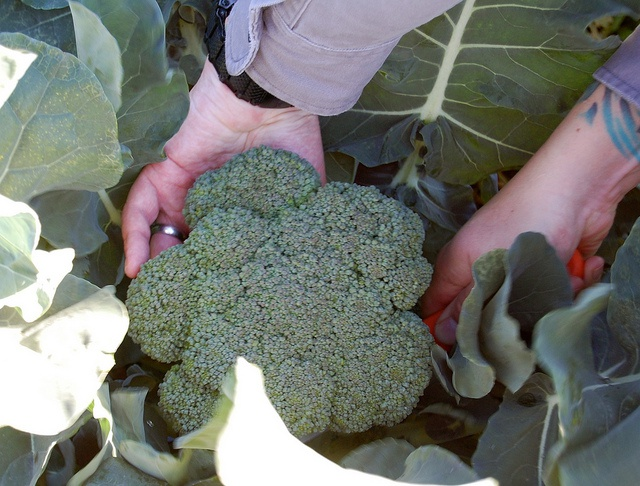Describe the objects in this image and their specific colors. I can see broccoli in black, gray, and darkgray tones, people in black, darkgray, lightpink, and pink tones, and people in black, darkgray, gray, and maroon tones in this image. 